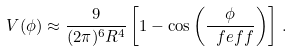Convert formula to latex. <formula><loc_0><loc_0><loc_500><loc_500>V ( \phi ) \approx \frac { 9 } { ( 2 \pi ) ^ { 6 } R ^ { 4 } } \left [ 1 - \cos \left ( \frac { \phi } { \ f e f f } \right ) \right ] \, .</formula> 